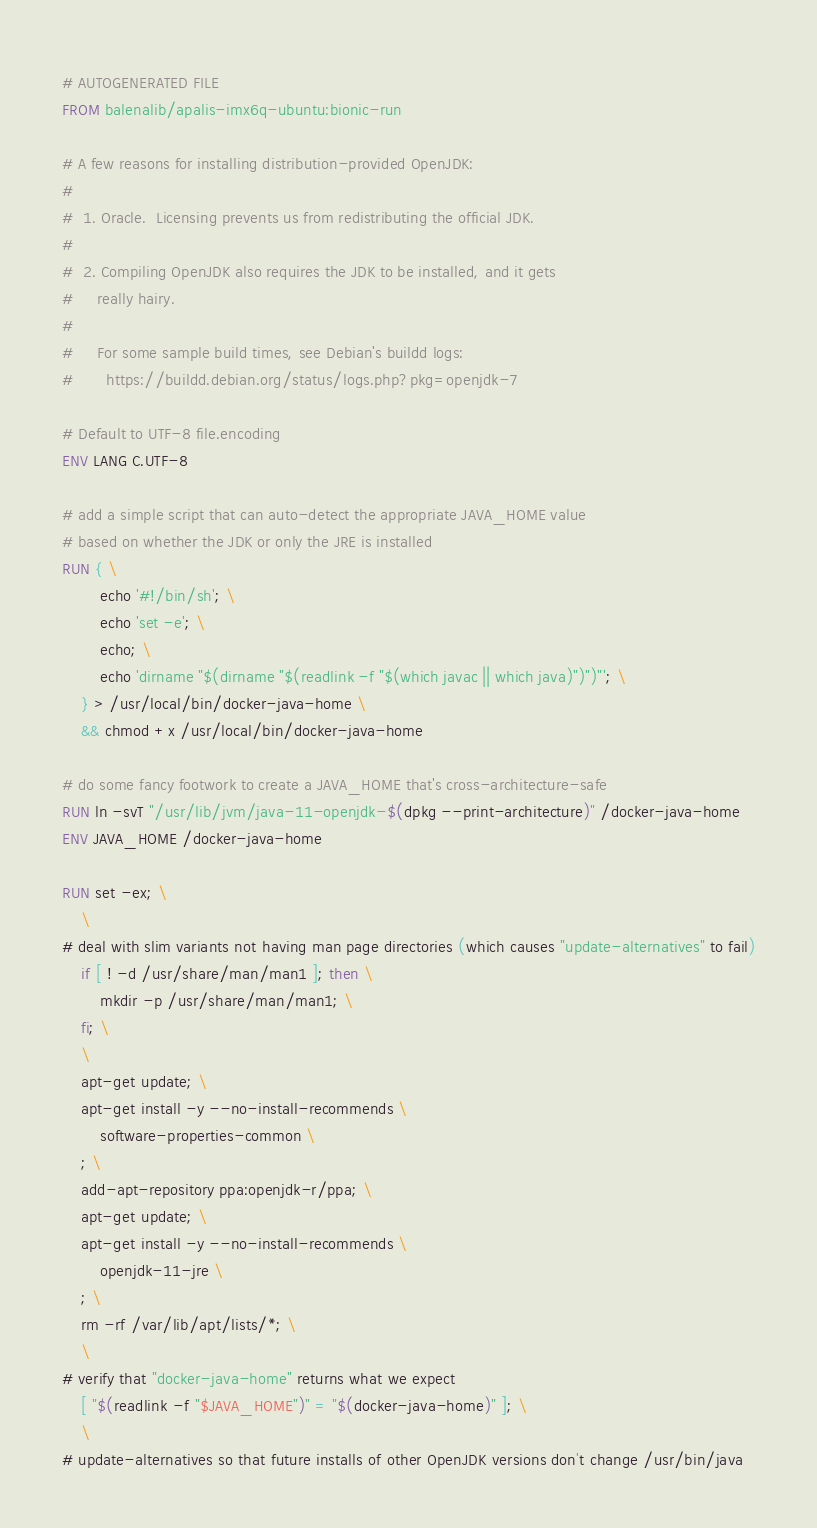<code> <loc_0><loc_0><loc_500><loc_500><_Dockerfile_># AUTOGENERATED FILE
FROM balenalib/apalis-imx6q-ubuntu:bionic-run

# A few reasons for installing distribution-provided OpenJDK:
#
#  1. Oracle.  Licensing prevents us from redistributing the official JDK.
#
#  2. Compiling OpenJDK also requires the JDK to be installed, and it gets
#     really hairy.
#
#     For some sample build times, see Debian's buildd logs:
#       https://buildd.debian.org/status/logs.php?pkg=openjdk-7

# Default to UTF-8 file.encoding
ENV LANG C.UTF-8

# add a simple script that can auto-detect the appropriate JAVA_HOME value
# based on whether the JDK or only the JRE is installed
RUN { \
		echo '#!/bin/sh'; \
		echo 'set -e'; \
		echo; \
		echo 'dirname "$(dirname "$(readlink -f "$(which javac || which java)")")"'; \
	} > /usr/local/bin/docker-java-home \
	&& chmod +x /usr/local/bin/docker-java-home

# do some fancy footwork to create a JAVA_HOME that's cross-architecture-safe
RUN ln -svT "/usr/lib/jvm/java-11-openjdk-$(dpkg --print-architecture)" /docker-java-home
ENV JAVA_HOME /docker-java-home

RUN set -ex; \
	\
# deal with slim variants not having man page directories (which causes "update-alternatives" to fail)
	if [ ! -d /usr/share/man/man1 ]; then \
		mkdir -p /usr/share/man/man1; \
	fi; \
	\
	apt-get update; \
	apt-get install -y --no-install-recommends \
		software-properties-common \
	; \
	add-apt-repository ppa:openjdk-r/ppa; \
	apt-get update; \
	apt-get install -y --no-install-recommends \
		openjdk-11-jre \
	; \
	rm -rf /var/lib/apt/lists/*; \
	\
# verify that "docker-java-home" returns what we expect
	[ "$(readlink -f "$JAVA_HOME")" = "$(docker-java-home)" ]; \
	\
# update-alternatives so that future installs of other OpenJDK versions don't change /usr/bin/java</code> 